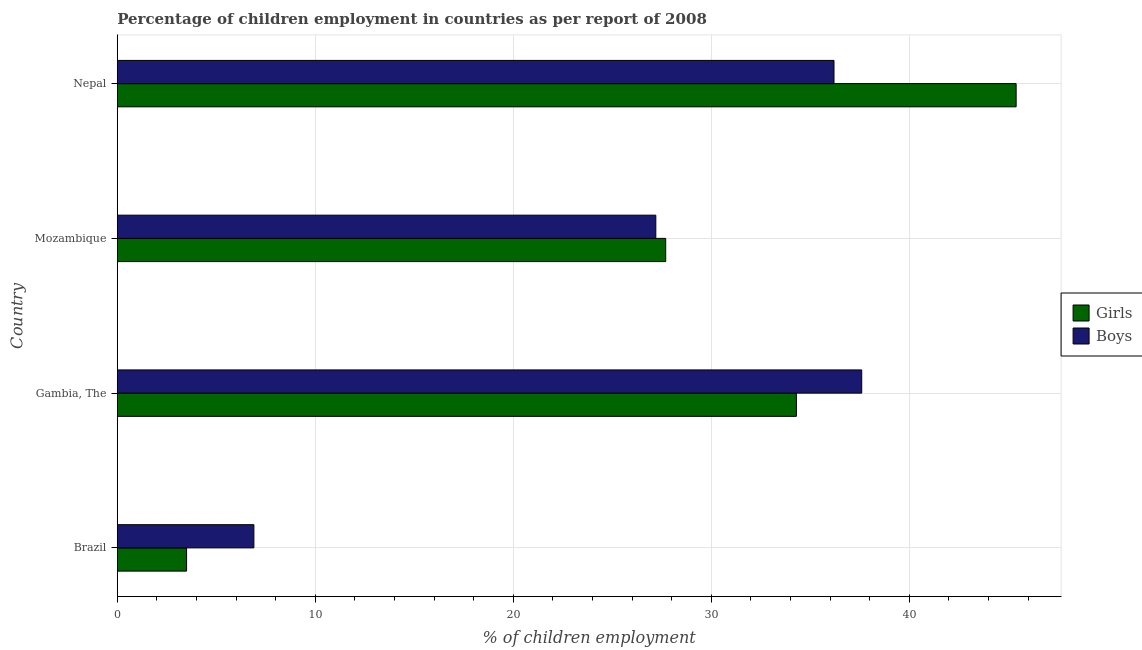Are the number of bars on each tick of the Y-axis equal?
Offer a very short reply. Yes. How many bars are there on the 4th tick from the top?
Keep it short and to the point. 2. How many bars are there on the 1st tick from the bottom?
Offer a terse response. 2. What is the label of the 2nd group of bars from the top?
Your response must be concise. Mozambique. What is the percentage of employed boys in Mozambique?
Provide a short and direct response. 27.2. Across all countries, what is the maximum percentage of employed girls?
Offer a terse response. 45.4. In which country was the percentage of employed boys maximum?
Ensure brevity in your answer.  Gambia, The. In which country was the percentage of employed boys minimum?
Offer a terse response. Brazil. What is the total percentage of employed boys in the graph?
Your answer should be compact. 107.9. What is the difference between the percentage of employed boys in Gambia, The and that in Mozambique?
Keep it short and to the point. 10.4. What is the difference between the percentage of employed boys in Gambia, The and the percentage of employed girls in Nepal?
Offer a very short reply. -7.8. What is the average percentage of employed boys per country?
Offer a terse response. 26.98. What is the ratio of the percentage of employed boys in Mozambique to that in Nepal?
Keep it short and to the point. 0.75. Is the difference between the percentage of employed boys in Brazil and Gambia, The greater than the difference between the percentage of employed girls in Brazil and Gambia, The?
Your response must be concise. Yes. What is the difference between the highest and the second highest percentage of employed girls?
Offer a very short reply. 11.1. What is the difference between the highest and the lowest percentage of employed girls?
Provide a short and direct response. 41.9. In how many countries, is the percentage of employed girls greater than the average percentage of employed girls taken over all countries?
Your answer should be compact. 2. Is the sum of the percentage of employed boys in Brazil and Nepal greater than the maximum percentage of employed girls across all countries?
Give a very brief answer. No. What does the 1st bar from the top in Mozambique represents?
Offer a terse response. Boys. What does the 1st bar from the bottom in Mozambique represents?
Make the answer very short. Girls. Are all the bars in the graph horizontal?
Make the answer very short. Yes. Does the graph contain any zero values?
Make the answer very short. No. Where does the legend appear in the graph?
Make the answer very short. Center right. What is the title of the graph?
Your answer should be very brief. Percentage of children employment in countries as per report of 2008. What is the label or title of the X-axis?
Your answer should be very brief. % of children employment. What is the label or title of the Y-axis?
Make the answer very short. Country. What is the % of children employment of Girls in Brazil?
Ensure brevity in your answer.  3.5. What is the % of children employment in Boys in Brazil?
Your answer should be very brief. 6.9. What is the % of children employment of Girls in Gambia, The?
Your response must be concise. 34.3. What is the % of children employment in Boys in Gambia, The?
Give a very brief answer. 37.6. What is the % of children employment in Girls in Mozambique?
Provide a short and direct response. 27.7. What is the % of children employment in Boys in Mozambique?
Ensure brevity in your answer.  27.2. What is the % of children employment of Girls in Nepal?
Your answer should be very brief. 45.4. What is the % of children employment of Boys in Nepal?
Your answer should be compact. 36.2. Across all countries, what is the maximum % of children employment in Girls?
Your answer should be compact. 45.4. Across all countries, what is the maximum % of children employment in Boys?
Give a very brief answer. 37.6. Across all countries, what is the minimum % of children employment in Girls?
Provide a succinct answer. 3.5. Across all countries, what is the minimum % of children employment of Boys?
Provide a short and direct response. 6.9. What is the total % of children employment of Girls in the graph?
Offer a very short reply. 110.9. What is the total % of children employment of Boys in the graph?
Provide a succinct answer. 107.9. What is the difference between the % of children employment in Girls in Brazil and that in Gambia, The?
Ensure brevity in your answer.  -30.8. What is the difference between the % of children employment in Boys in Brazil and that in Gambia, The?
Make the answer very short. -30.7. What is the difference between the % of children employment in Girls in Brazil and that in Mozambique?
Provide a succinct answer. -24.2. What is the difference between the % of children employment in Boys in Brazil and that in Mozambique?
Make the answer very short. -20.3. What is the difference between the % of children employment of Girls in Brazil and that in Nepal?
Your answer should be compact. -41.9. What is the difference between the % of children employment of Boys in Brazil and that in Nepal?
Your response must be concise. -29.3. What is the difference between the % of children employment of Girls in Gambia, The and that in Mozambique?
Offer a very short reply. 6.6. What is the difference between the % of children employment of Boys in Gambia, The and that in Mozambique?
Provide a succinct answer. 10.4. What is the difference between the % of children employment in Girls in Gambia, The and that in Nepal?
Make the answer very short. -11.1. What is the difference between the % of children employment of Boys in Gambia, The and that in Nepal?
Give a very brief answer. 1.4. What is the difference between the % of children employment of Girls in Mozambique and that in Nepal?
Offer a very short reply. -17.7. What is the difference between the % of children employment in Girls in Brazil and the % of children employment in Boys in Gambia, The?
Your response must be concise. -34.1. What is the difference between the % of children employment in Girls in Brazil and the % of children employment in Boys in Mozambique?
Give a very brief answer. -23.7. What is the difference between the % of children employment in Girls in Brazil and the % of children employment in Boys in Nepal?
Your answer should be compact. -32.7. What is the difference between the % of children employment of Girls in Gambia, The and the % of children employment of Boys in Mozambique?
Your response must be concise. 7.1. What is the difference between the % of children employment of Girls in Mozambique and the % of children employment of Boys in Nepal?
Provide a short and direct response. -8.5. What is the average % of children employment in Girls per country?
Your response must be concise. 27.73. What is the average % of children employment of Boys per country?
Offer a terse response. 26.98. What is the ratio of the % of children employment in Girls in Brazil to that in Gambia, The?
Offer a terse response. 0.1. What is the ratio of the % of children employment in Boys in Brazil to that in Gambia, The?
Ensure brevity in your answer.  0.18. What is the ratio of the % of children employment in Girls in Brazil to that in Mozambique?
Your answer should be very brief. 0.13. What is the ratio of the % of children employment in Boys in Brazil to that in Mozambique?
Offer a very short reply. 0.25. What is the ratio of the % of children employment in Girls in Brazil to that in Nepal?
Keep it short and to the point. 0.08. What is the ratio of the % of children employment in Boys in Brazil to that in Nepal?
Your answer should be very brief. 0.19. What is the ratio of the % of children employment in Girls in Gambia, The to that in Mozambique?
Provide a succinct answer. 1.24. What is the ratio of the % of children employment in Boys in Gambia, The to that in Mozambique?
Ensure brevity in your answer.  1.38. What is the ratio of the % of children employment of Girls in Gambia, The to that in Nepal?
Keep it short and to the point. 0.76. What is the ratio of the % of children employment in Boys in Gambia, The to that in Nepal?
Your answer should be very brief. 1.04. What is the ratio of the % of children employment of Girls in Mozambique to that in Nepal?
Your answer should be very brief. 0.61. What is the ratio of the % of children employment in Boys in Mozambique to that in Nepal?
Offer a terse response. 0.75. What is the difference between the highest and the second highest % of children employment in Boys?
Provide a succinct answer. 1.4. What is the difference between the highest and the lowest % of children employment of Girls?
Give a very brief answer. 41.9. What is the difference between the highest and the lowest % of children employment in Boys?
Your answer should be very brief. 30.7. 